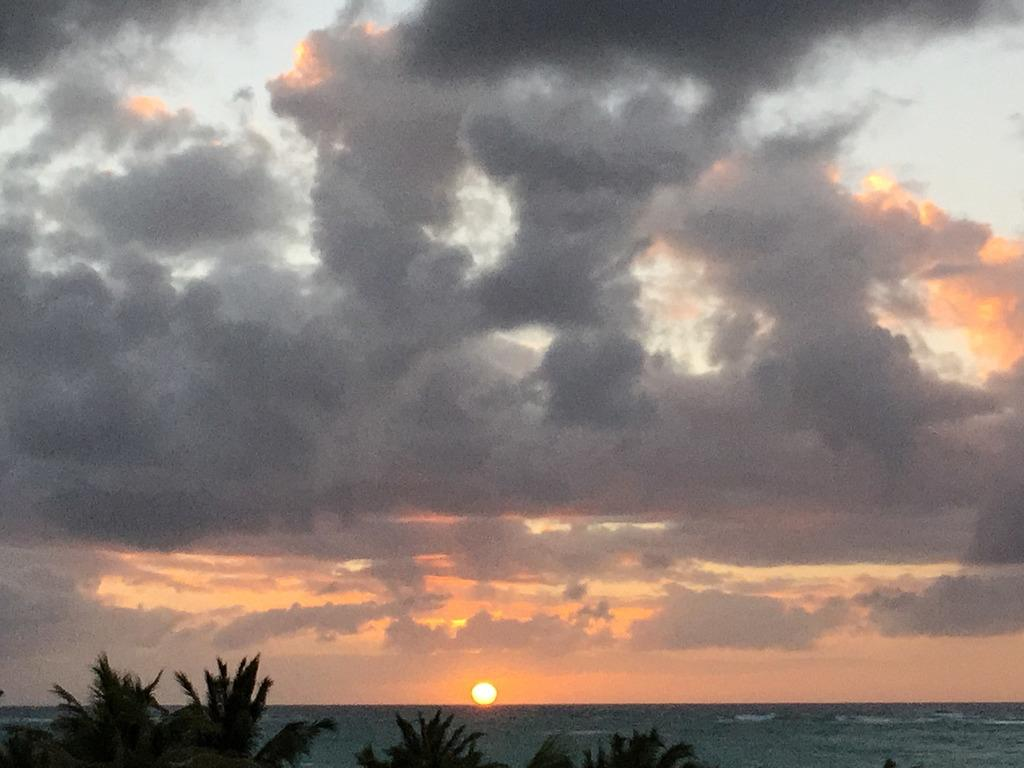What type of vegetation can be seen in the image? There are trees in the image. What natural element is visible in the image? Water is visible in the image. Can the sun be seen in the image? Yes, the sun is observable in the image. What part of the sky is visible in the image? The sky is visible in the image. What atmospheric feature can be seen in the sky? Clouds are present in the sky. What type of marble can be seen on the ground in the image? There is no marble present in the image; it features trees, water, and a sky with clouds. Where is the store located in the image? There is no store present in the image. 